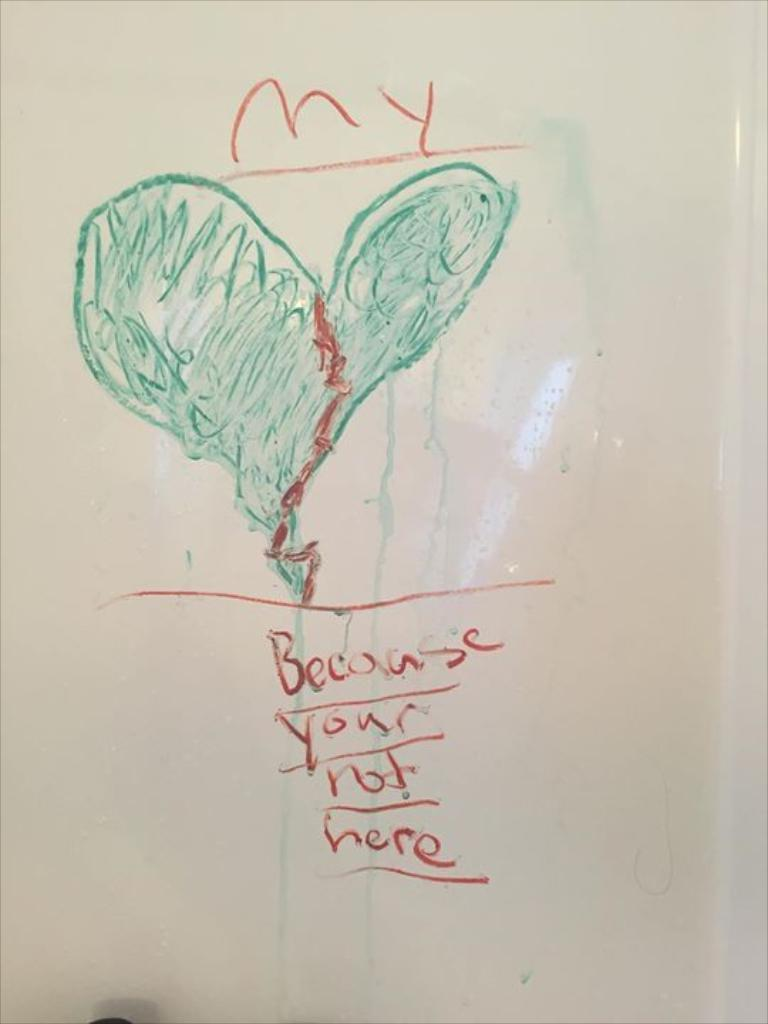What is depicted in the drawing in the image? There is a drawing of a heart in the image. What else can be seen in the image besides the drawing? There is text on a white surface in the image. What song is being played in the background of the image? There is no indication of any song being played in the image; it only contains a drawing of a heart and text on a white surface. 